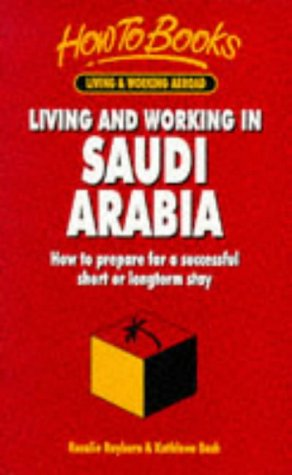What is the title of this book? The complete title of this insightful guide is 'Living & Working in Saudi Arabia: How to Prepare for a Successful Short or Longterm Stay (Living & Working Abroad)'. 